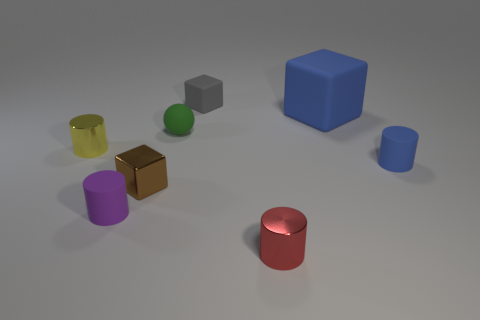What number of matte things are yellow things or tiny red things?
Provide a short and direct response. 0. Is there another tiny object that has the same material as the small brown thing?
Your answer should be compact. Yes. What is the material of the big thing?
Provide a short and direct response. Rubber. What shape is the blue rubber thing behind the blue thing that is in front of the metallic cylinder on the left side of the green matte object?
Offer a terse response. Cube. Is the number of yellow shiny objects left of the yellow metal cylinder greater than the number of gray rubber cubes?
Provide a succinct answer. No. Does the tiny brown thing have the same shape as the small metallic object on the left side of the small purple rubber object?
Ensure brevity in your answer.  No. There is a small thing that is the same color as the big matte thing; what is its shape?
Your answer should be compact. Cylinder. What number of cylinders are behind the tiny matte cylinder that is left of the tiny shiny cylinder that is in front of the blue cylinder?
Keep it short and to the point. 2. What color is the sphere that is the same size as the blue cylinder?
Give a very brief answer. Green. There is a rubber thing on the left side of the tiny green rubber object to the right of the yellow object; what is its size?
Provide a short and direct response. Small. 